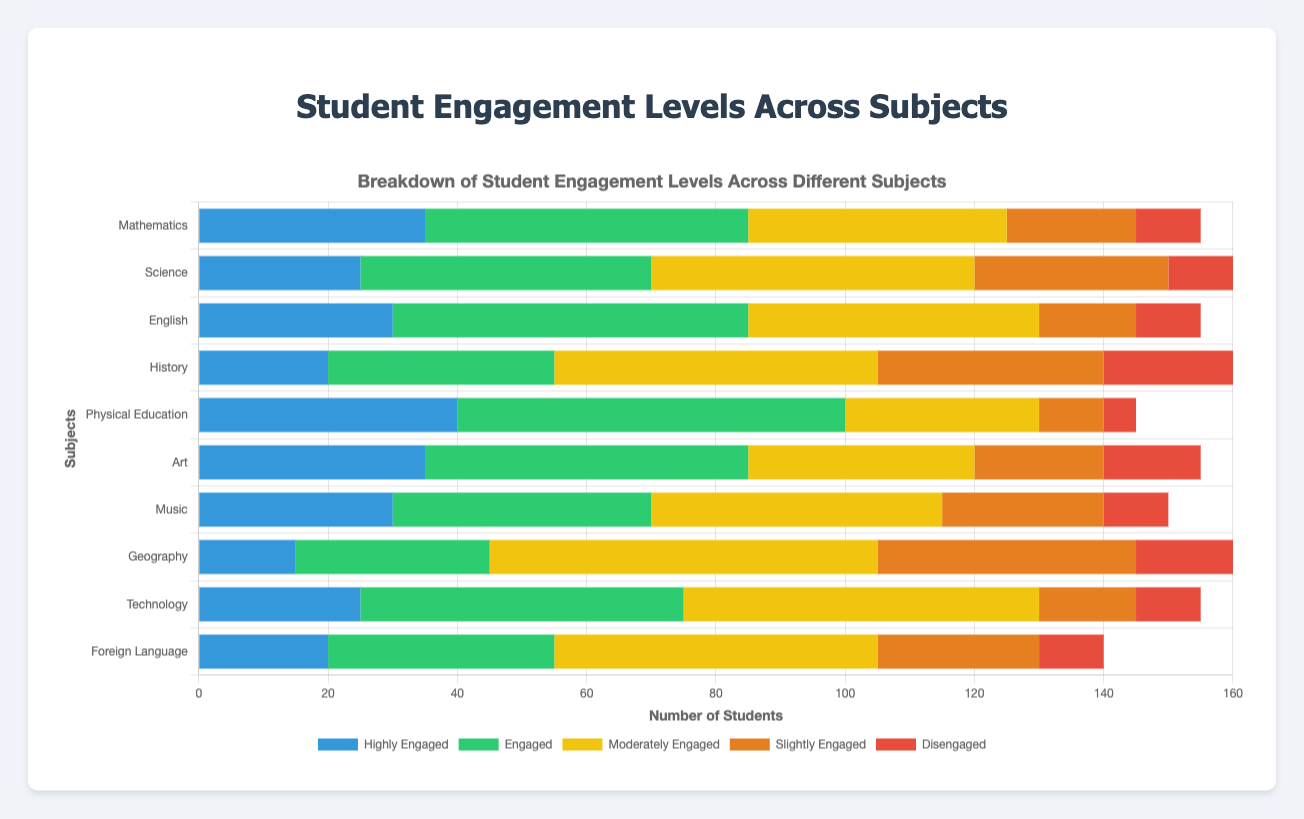Which subject has the highest number of Highly Engaged students? The bar representing Physical Education has the highest value for Highly Engaged students, as it is the tallest blue bar.
Answer: Physical Education Which subject has the lowest number of Disengaged students? The bar representing Physical Education has the lowest value for Disengaged students, as it is the shortest red bar.
Answer: Physical Education How many more Highly Engaged students are there in Mathematics compared to Science? The number of Highly Engaged students in Mathematics is 35 and in Science is 25. The difference is 35 - 25 = 10.
Answer: 10 Which two subjects have equal numbers of Disengaged students? Both Mathematics and Science have 10 Disengaged students, as indicated by the length of the red bars.
Answer: Mathematics and Science What is the total number of students Engaged and Moderately Engaged in English? The number of Engaged students in English is 55, and the number of Moderately Engaged students is 45. The total is 55 + 45 = 100.
Answer: 100 Which subject has the greatest difference between Highly Engaged and Disengaged students? The greatest difference is in Physical Education. Highly Engaged students are 40 and Disengaged students are 5. The difference is 40 - 5 = 35.
Answer: Physical Education What is the average number of Slightly Engaged students across all subjects? The number of Slightly Engaged students across all subjects is 20 + 30 + 15 + 35 + 10 + 20 + 25 + 40 + 15 + 25 = 235. There are 10 subjects, so the average is 235 / 10 = 23.5.
Answer: 23.5 Which subject shows the smallest discrepancy between Engaged and Moderately Engaged students? For Science, Engaged students are 45 and Moderately Engaged students are 50, with a difference of 5. This is the smallest discrepancy among all subjects.
Answer: Science In how many subjects is the number of Disengaged students equal to or less than 10? The number of Disengaged students equal to or less than 10 appear in Mathematics, Science, English, Physical Education, Music, Technology, and Foreign Language. This totals 7 out of 10 subjects.
Answer: 7 Which subject has the highest proportion of students Engaged compared to the total number of Engaged and Moderately Engaged students in that subject? Physical Education has 60 Engaged students and 30 Moderately Engaged students. The proportion is 60 / (60 + 30) = 2/3 or approximately 66.7%.
Answer: Physical Education 